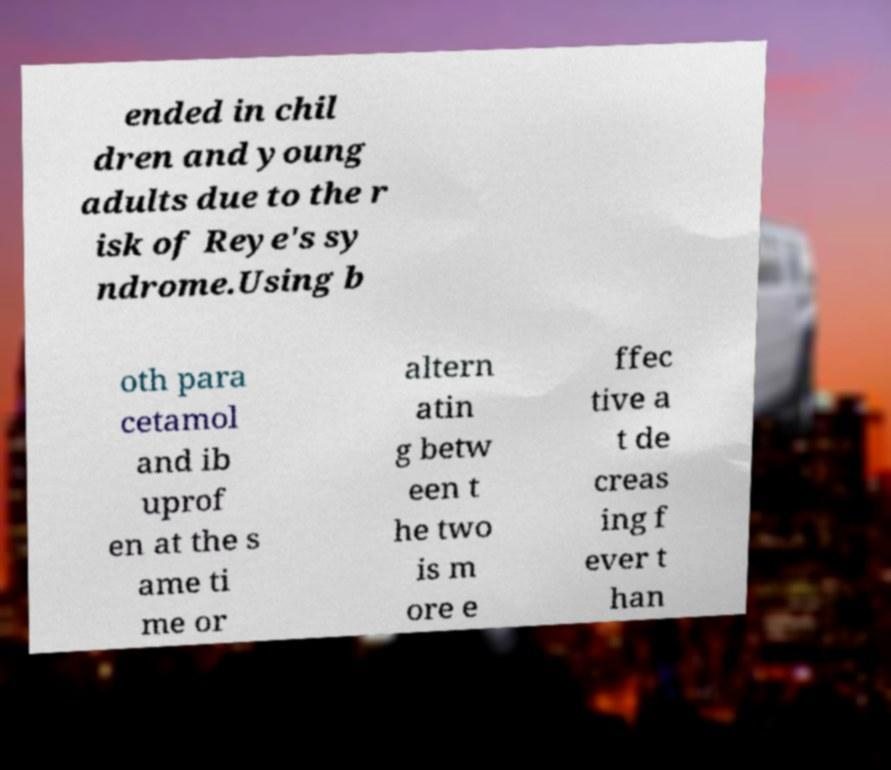Please identify and transcribe the text found in this image. ended in chil dren and young adults due to the r isk of Reye's sy ndrome.Using b oth para cetamol and ib uprof en at the s ame ti me or altern atin g betw een t he two is m ore e ffec tive a t de creas ing f ever t han 